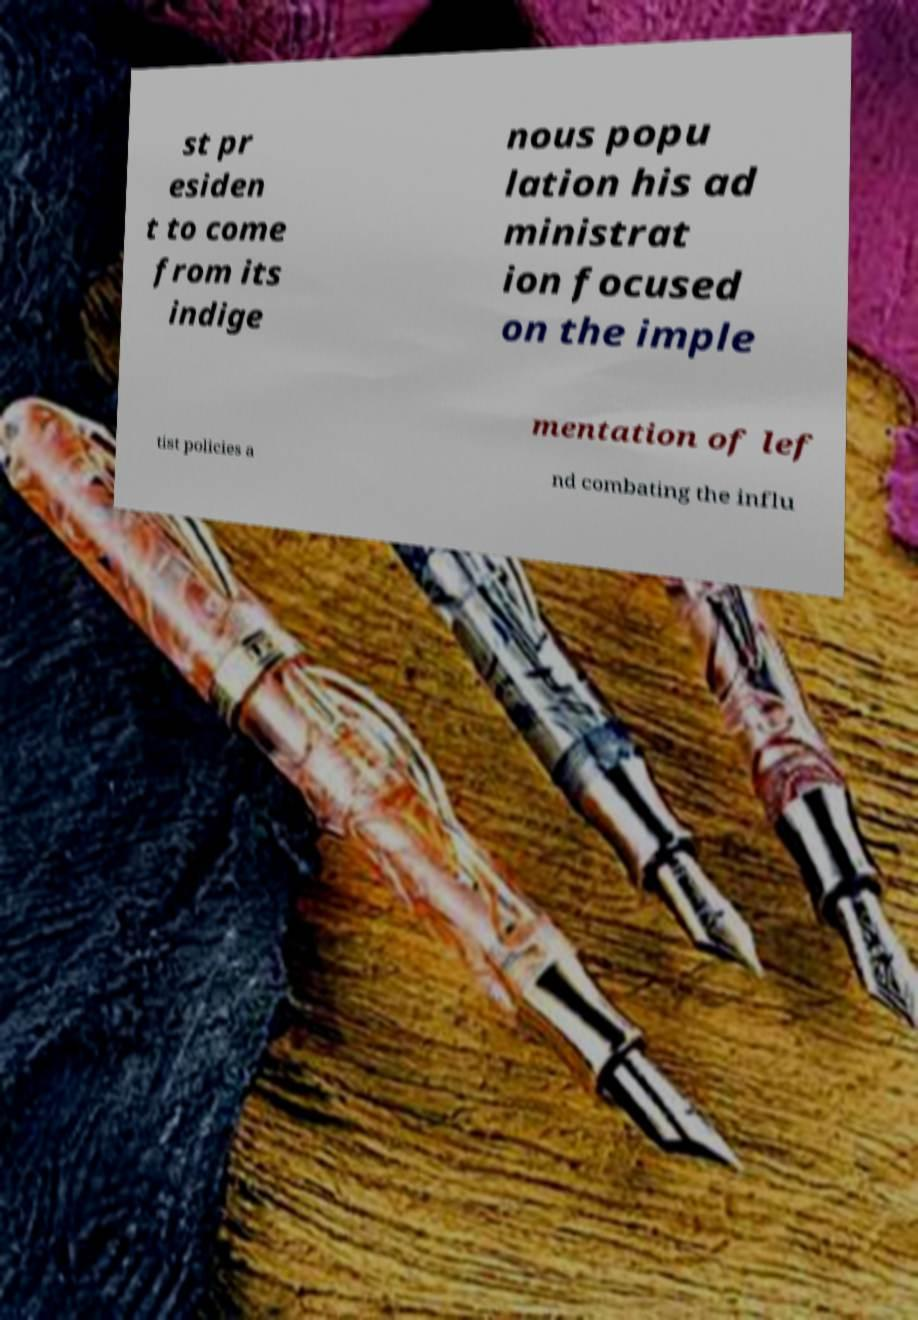For documentation purposes, I need the text within this image transcribed. Could you provide that? st pr esiden t to come from its indige nous popu lation his ad ministrat ion focused on the imple mentation of lef tist policies a nd combating the influ 